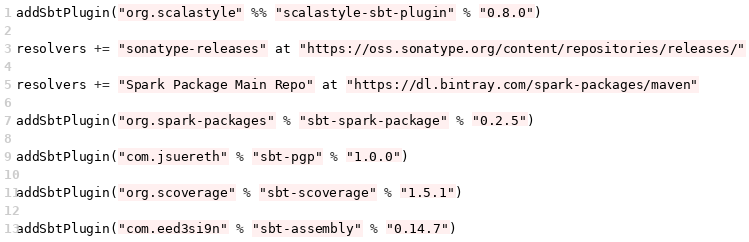Convert code to text. <code><loc_0><loc_0><loc_500><loc_500><_Scala_>addSbtPlugin("org.scalastyle" %% "scalastyle-sbt-plugin" % "0.8.0")

resolvers += "sonatype-releases" at "https://oss.sonatype.org/content/repositories/releases/"

resolvers += "Spark Package Main Repo" at "https://dl.bintray.com/spark-packages/maven"

addSbtPlugin("org.spark-packages" % "sbt-spark-package" % "0.2.5")

addSbtPlugin("com.jsuereth" % "sbt-pgp" % "1.0.0")

addSbtPlugin("org.scoverage" % "sbt-scoverage" % "1.5.1")

addSbtPlugin("com.eed3si9n" % "sbt-assembly" % "0.14.7")
</code> 